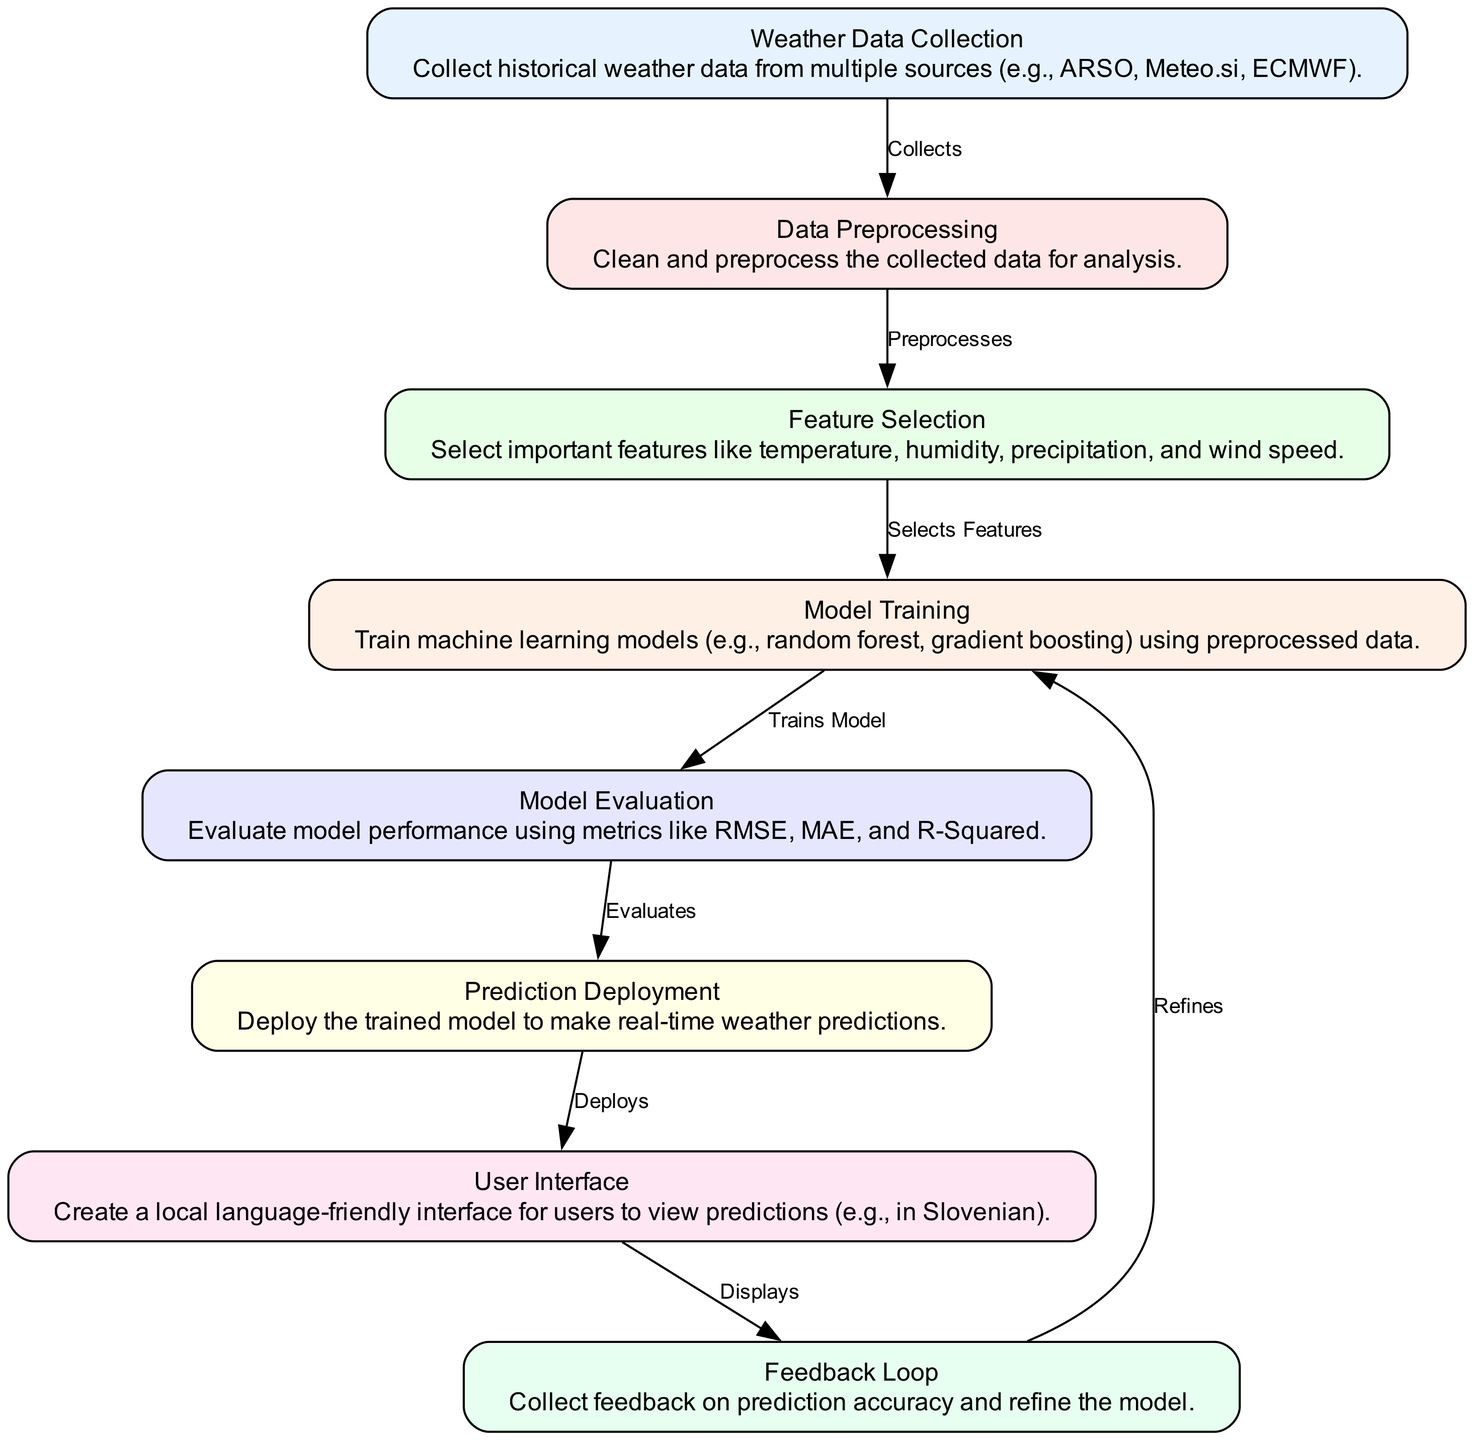What is the first step in the local weather prediction process? The diagram shows that the first node is "Weather Data Collection," indicating that collecting historical weather data is the initial step in the local weather prediction process.
Answer: Weather Data Collection How many nodes are present in the diagram? Upon examining the diagram, there are eight nodes described within it, each representing a specific step or component in the weather prediction process.
Answer: Eight Which model is trained after feature selection? From the flow of the diagram, after "Feature Selection," the next node is "Model Training," which indicates that the model is trained using the selected features.
Answer: Model Training What is the main purpose of the User Interface node? The diagram specifies that the "User Interface" node is responsible for creating a friendly interface for users to view predictions, suggesting its purpose is to facilitate user interaction with the weather predictions.
Answer: Create a local language-friendly interface for users to view predictions How does the Feedback Loop influence the diagram? The "Feedback Loop" node connects back to "Model Training," indicating that feedback on prediction accuracy is used to refine and improve the training of the model, showcasing a cyclic improvement process.
Answer: Refines What type of machine learning models are mentioned in the Model Training step? The description of the "Model Training" node indicates that various machine learning models, specifically random forest and gradient boosting, are utilized in this step for training the model.
Answer: Random forest, gradient boosting How is model performance evaluated? According to the "Model Evaluation" node in the diagram, model performance is evaluated using metrics such as RMSE, MAE, and R-Squared, which provide quantitative measures of the model's accuracy and reliability.
Answer: RMSE, MAE, R-Squared What is the relationship between Prediction Deployment and User Interface? The diagram shows an edge labeled "Deploys" from "Prediction Deployment" to "User Interface," indicating that the trained model's predictions are deployed to be displayed within the user interface.
Answer: Deploys 